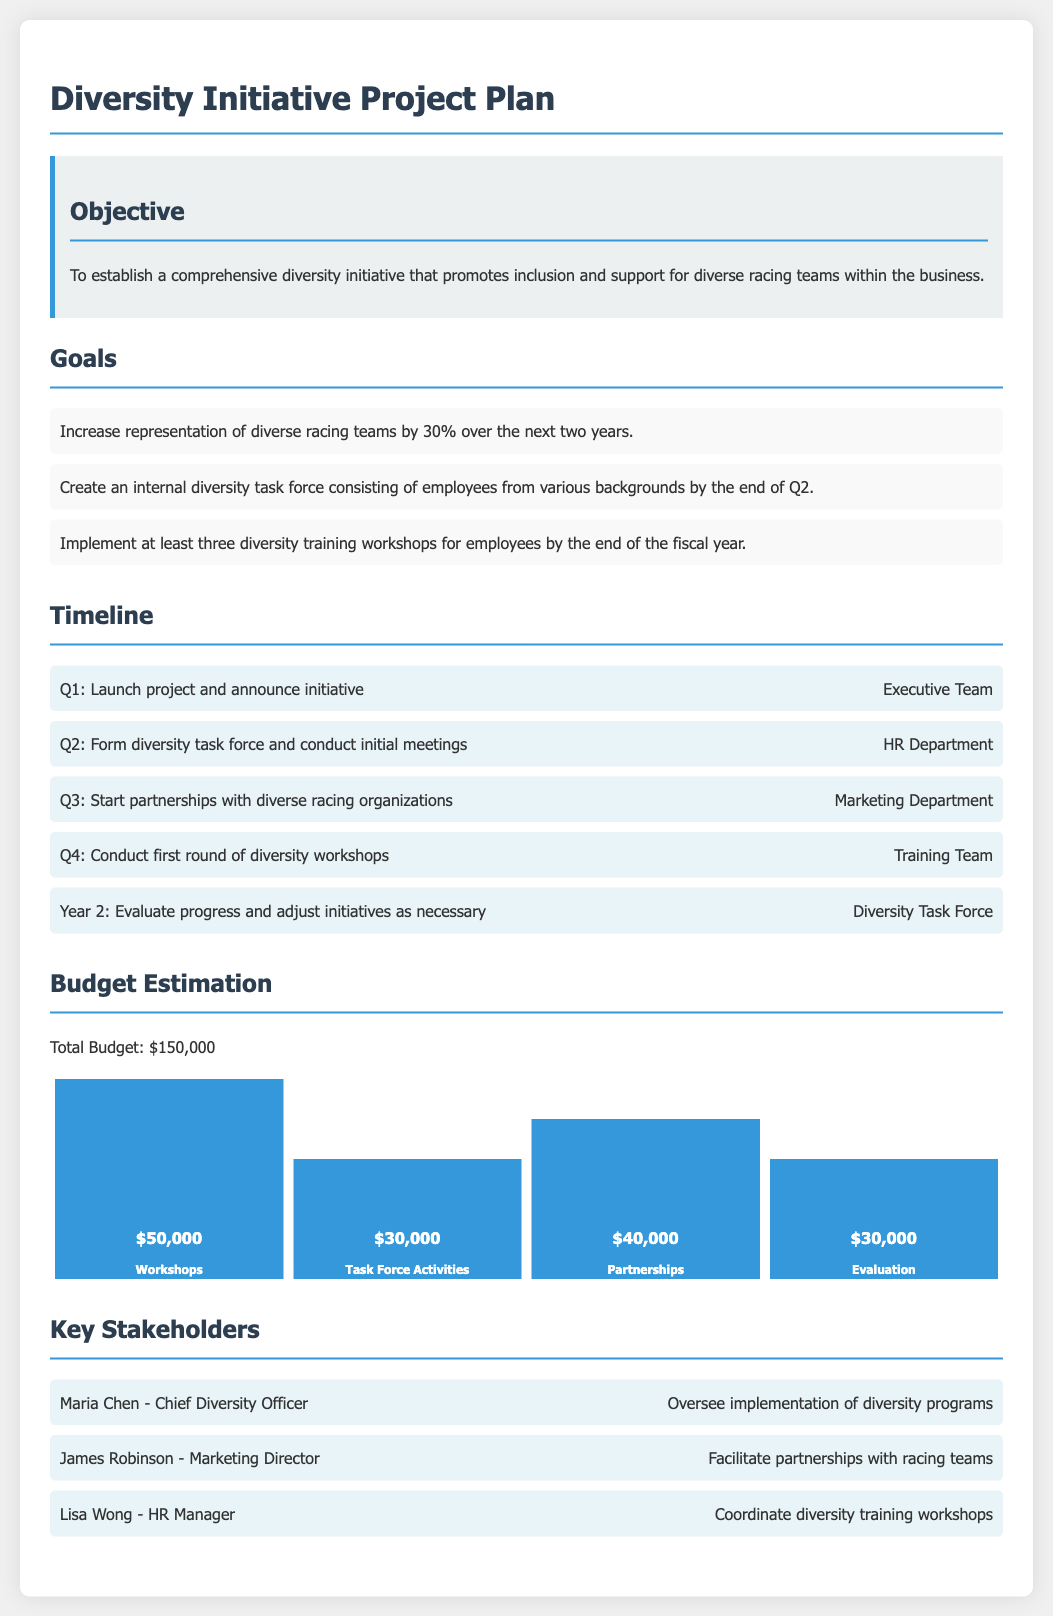What is the total budget for the diversity initiative? The total budget for the diversity initiative is provided in the budget estimation section.
Answer: $150,000 When is the first round of diversity workshops scheduled? The timeline outlines that the first round of diversity workshops will occur in Q4.
Answer: Q4 Who is the Chief Diversity Officer mentioned in the document? The document lists key stakeholders and identifies Maria Chen as the Chief Diversity Officer.
Answer: Maria Chen How much budget is allocated for workshops? The budget estimation details that $50,000 is allocated for workshops.
Answer: $50,000 What percentage increase in representation of diverse racing teams is targeted? The goals section states that the objective is to increase representation by 30%.
Answer: 30% What department is responsible for forming the diversity task force? The timeline specifies that the HR Department is responsible for forming the diversity task force.
Answer: HR Department Name one goal of the diversity initiative. The goals section lists several goals, one of which is to implement at least three diversity training workshops.
Answer: Implement at least three diversity training workshops What action is scheduled for Q3 in the timeline? The timeline indicates that in Q3, partnerships with diverse racing organizations will start.
Answer: Start partnerships with diverse racing organizations Who is coordinating the diversity training workshops? Among the key stakeholders, Lisa Wong is identified as coordinating the diversity training workshops.
Answer: Lisa Wong 